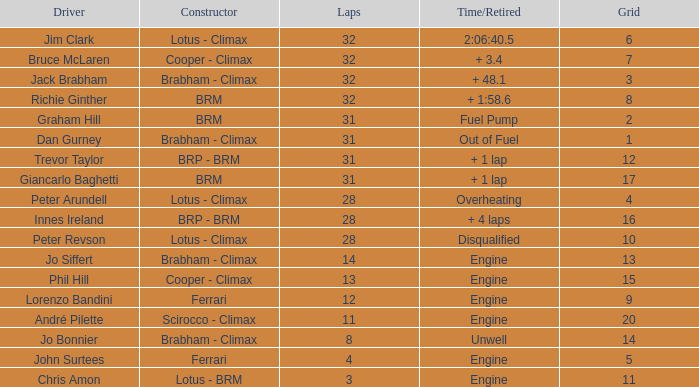What is the typical grid spot for jack brabham during a 32-lap race? None. 